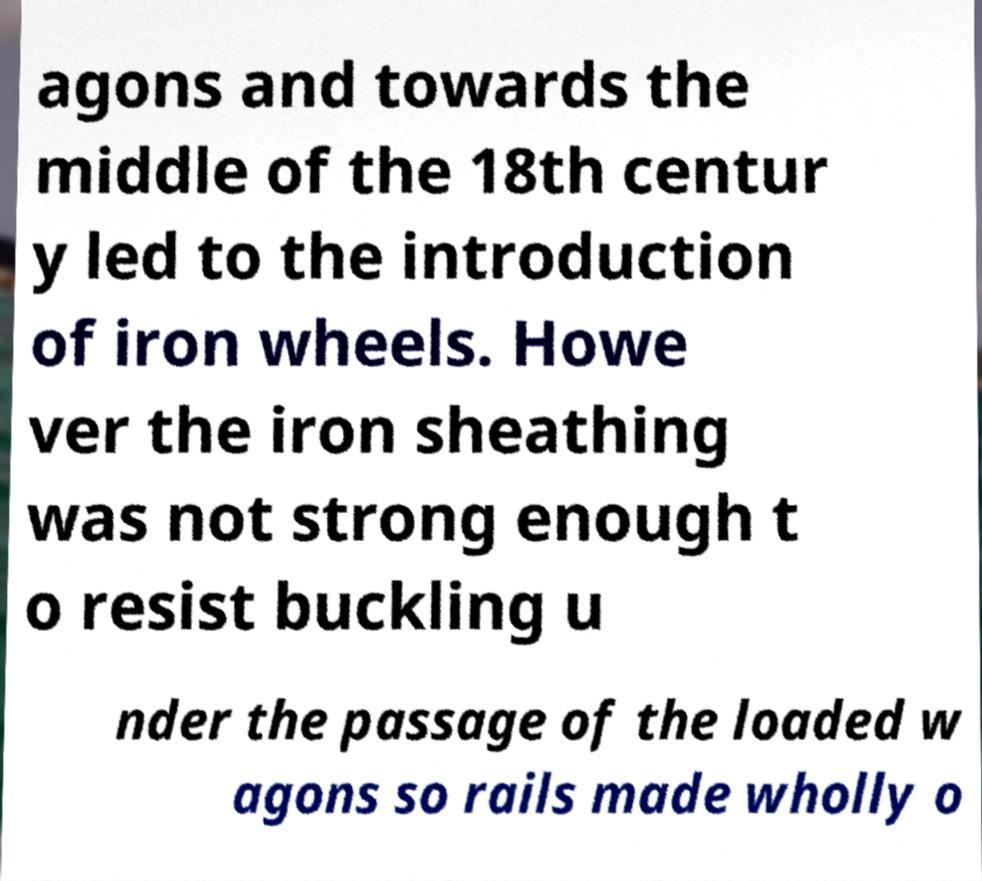Please identify and transcribe the text found in this image. agons and towards the middle of the 18th centur y led to the introduction of iron wheels. Howe ver the iron sheathing was not strong enough t o resist buckling u nder the passage of the loaded w agons so rails made wholly o 